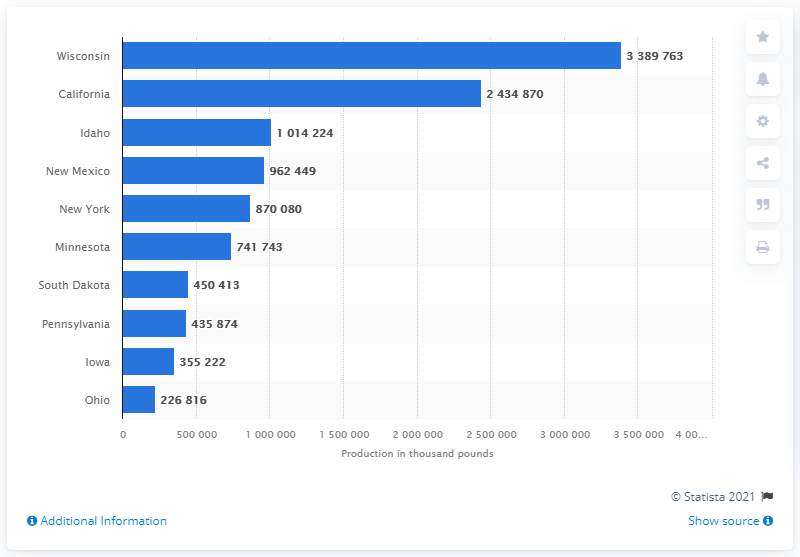List a handful of essential elements in this visual. Wisconsin was the state with the highest cheese production in 2020. 